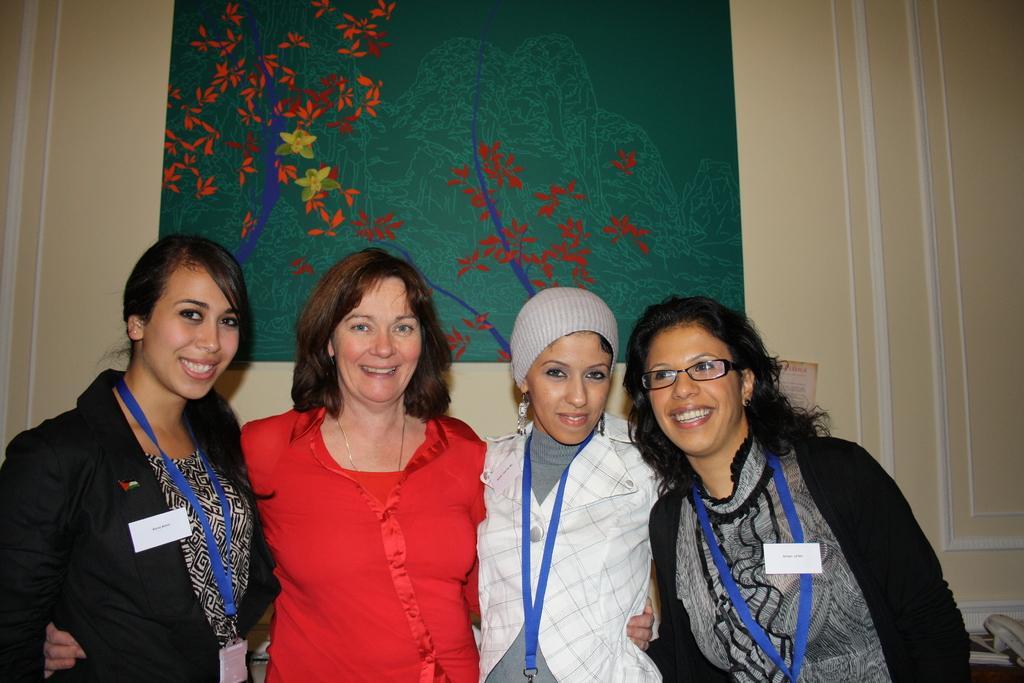How would you summarize this image in a sentence or two? This image consists of a woman. They are wearing tags. In the background, there is wall on which there is a frame in green color. 